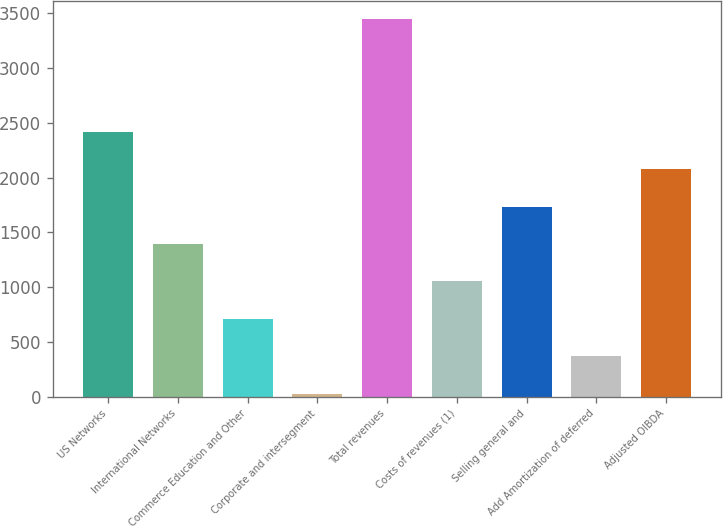Convert chart to OTSL. <chart><loc_0><loc_0><loc_500><loc_500><bar_chart><fcel>US Networks<fcel>International Networks<fcel>Commerce Education and Other<fcel>Corporate and intersegment<fcel>Total revenues<fcel>Costs of revenues (1)<fcel>Selling general and<fcel>Add Amortization of deferred<fcel>Adjusted OIBDA<nl><fcel>2418.2<fcel>1393.4<fcel>710.2<fcel>27<fcel>3443<fcel>1051.8<fcel>1735<fcel>368.6<fcel>2076.6<nl></chart> 